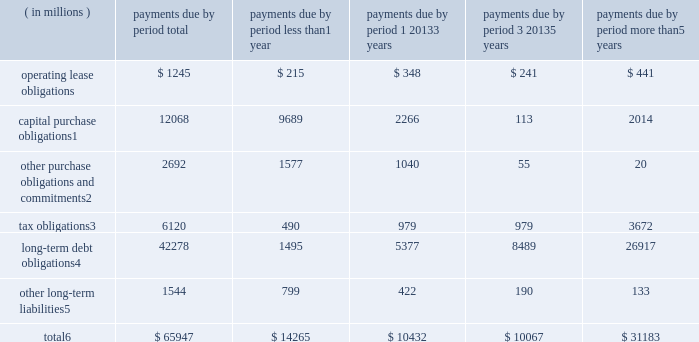Contractual obligations significant contractual obligations as of december 30 , 2017 were as follows: .
Capital purchase obligations1 12068 9689 2266 113 2014 other purchase obligations and commitments2 2692 1577 1040 55 20 tax obligations3 6120 490 979 979 3672 long-term debt obligations4 42278 1495 5377 8489 26917 other long-term liabilities5 1544 799 422 190 133 total6 $ 65947 $ 14265 $ 10432 $ 10067 $ 31183 1 capital purchase obligations represent commitments for the construction or purchase of property , plant and equipment .
They were not recorded as liabilities on our consolidated balance sheets as of december 30 , 2017 , as we had not yet received the related goods nor taken title to the property .
2 other purchase obligations and commitments include payments due under various types of licenses and agreements to purchase goods or services , as well as payments due under non-contingent funding obligations .
3 tax obligations represent the future cash payments related to tax reform enacted in 2017 for the one-time provisional transition tax on our previously untaxed foreign earnings .
For further information , see 201cnote 8 : income taxes 201d within the consolidated financial statements .
4 amounts represent principal and interest cash payments over the life of the debt obligations , including anticipated interest payments that are not recorded on our consolidated balance sheets .
Debt obligations are classified based on their stated maturity date , regardless of their classification on the consolidated balance sheets .
Any future settlement of convertible debt would impact our cash payments .
5 amounts represent future cash payments to satisfy other long-term liabilities recorded on our consolidated balance sheets , including the short-term portion of these long-term liabilities .
Derivative instruments are excluded from the preceding table , as they do not represent the amounts that may ultimately be paid .
6 total excludes contractual obligations already recorded on our consolidated balance sheets as current liabilities , except for the short-term portions of long-term debt obligations and other long-term liabilities .
The expected timing of payments of the obligations in the preceding table is estimated based on current information .
Timing of payments and actual amounts paid may be different , depending on the time of receipt of goods or services , or changes to agreed- upon amounts for some obligations .
Contractual obligations for purchases of goods or services included in 201cother purchase obligations and commitments 201d in the preceding table include agreements that are enforceable and legally binding on intel and that specify all significant terms , including fixed or minimum quantities to be purchased ; fixed , minimum , or variable price provisions ; and the approximate timing of the transaction .
For obligations with cancellation provisions , the amounts included in the preceding table were limited to the non-cancelable portion of the agreement terms or the minimum cancellation fee .
For the purchase of raw materials , we have entered into certain agreements that specify minimum prices and quantities based on a percentage of the total available market or based on a percentage of our future purchasing requirements .
Due to the uncertainty of the future market and our future purchasing requirements , as well as the non-binding nature of these agreements , obligations under these agreements have been excluded from the preceding table .
Our purchase orders for other products are based on our current manufacturing needs and are fulfilled by our vendors within short time horizons .
In addition , some of our purchase orders represent authorizations to purchase rather than binding agreements .
Contractual obligations that are contingent upon the achievement of certain milestones have been excluded from the preceding table .
Most of our milestone-based contracts are tooling related for the purchase of capital equipment .
These arrangements are not considered contractual obligations until the milestone is met by the counterparty .
As of december 30 , 2017 , assuming that all future milestones are met , the additional required payments would be approximately $ 2.0 billion .
For the majority of restricted stock units ( rsus ) granted , the number of shares of common stock issued on the date the rsus vest is net of the minimum statutory withholding requirements that we pay in cash to the appropriate taxing authorities on behalf of our employees .
The obligation to pay the relevant taxing authority is excluded from the preceding table , as the amount is contingent upon continued employment .
In addition , the amount of the obligation is unknown , as it is based in part on the market price of our common stock when the awards vest .
Md&a - results of operations consolidated results and analysis 38 .
As of december 30 , 2017 what was the percent of the operating lease obligations to the total? 
Rationale: as of december 30 , 2017 1.8% of the total was made of the operating lease obligations
Computations: (1245 / 65947)
Answer: 0.01888. 